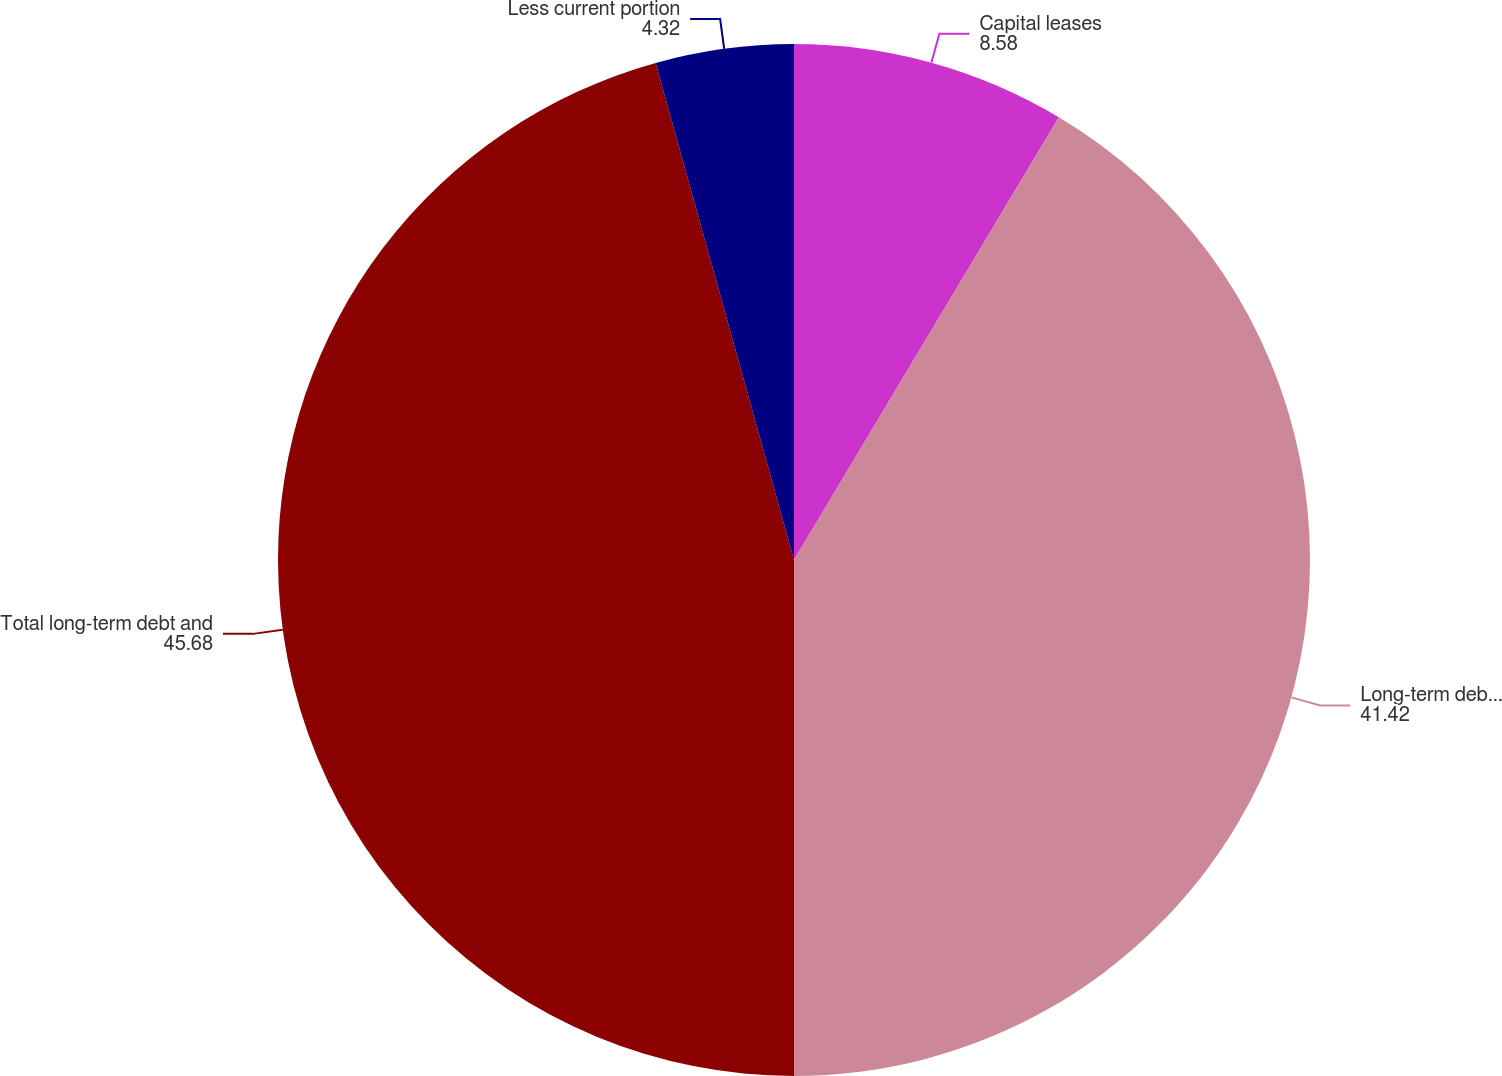Convert chart. <chart><loc_0><loc_0><loc_500><loc_500><pie_chart><fcel>Capital leases<fcel>Long-term debt (excluding<fcel>Total long-term debt and<fcel>Less current portion<nl><fcel>8.58%<fcel>41.42%<fcel>45.68%<fcel>4.32%<nl></chart> 